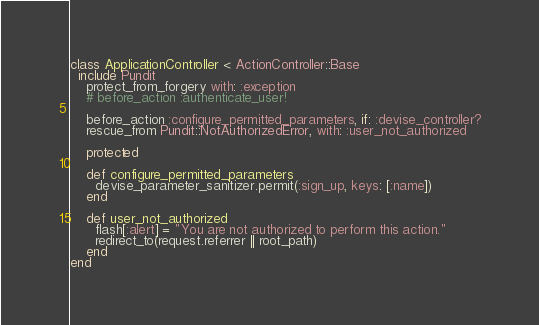Convert code to text. <code><loc_0><loc_0><loc_500><loc_500><_Ruby_>class ApplicationController < ActionController::Base
  include Pundit
    protect_from_forgery with: :exception
    # before_action :authenticate_user!

    before_action :configure_permitted_parameters, if: :devise_controller?
    rescue_from Pundit::NotAuthorizedError, with: :user_not_authorized

    protected

    def configure_permitted_parameters
      devise_parameter_sanitizer.permit(:sign_up, keys: [:name])
    end

    def user_not_authorized
      flash[:alert] = "You are not authorized to perform this action."
      redirect_to(request.referrer || root_path)
    end
end
</code> 